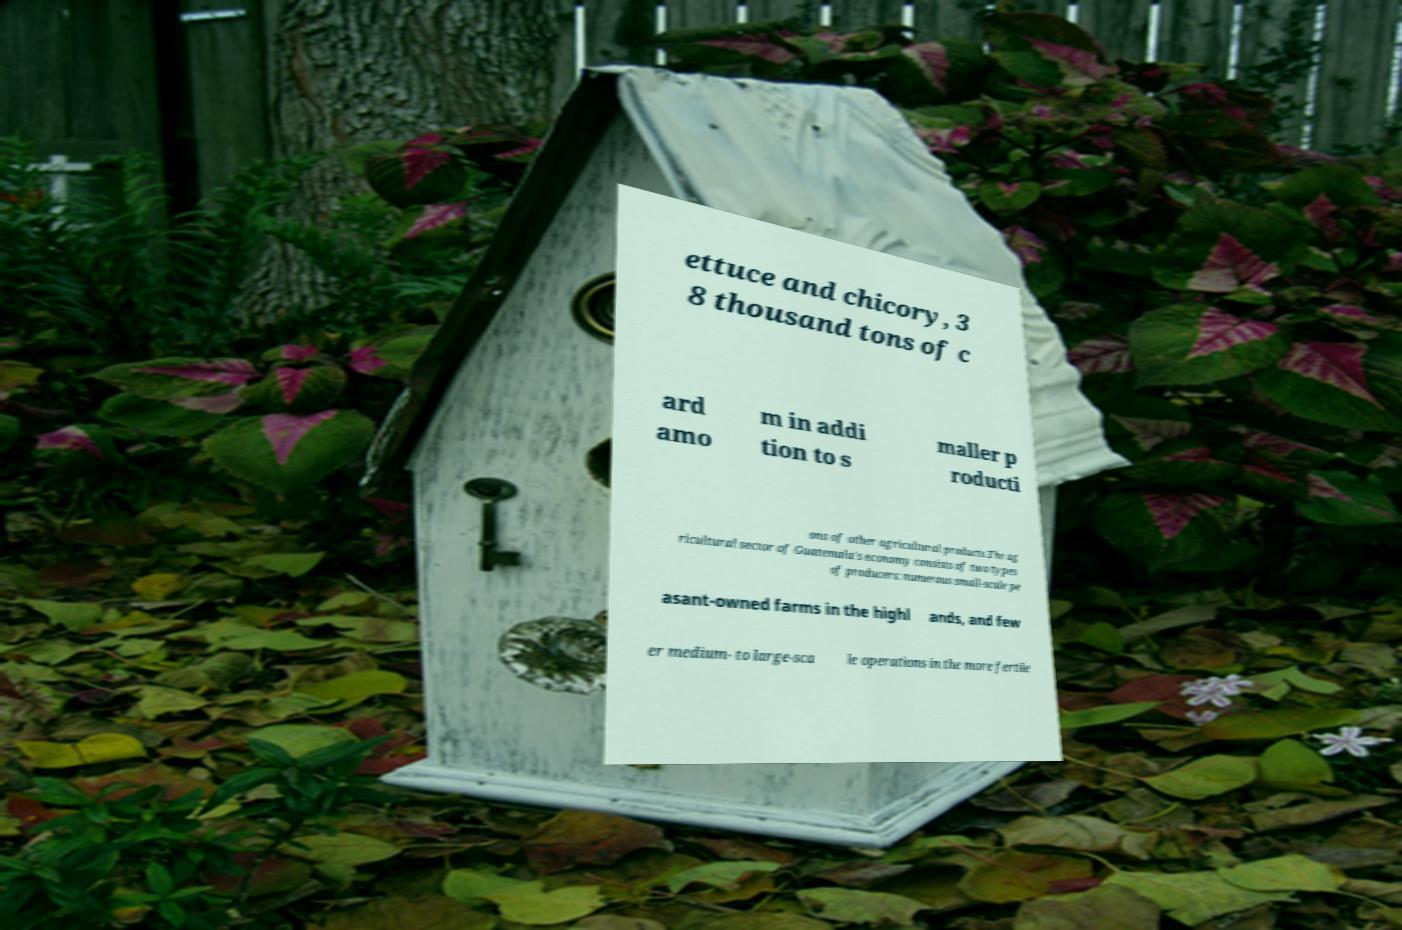Please read and relay the text visible in this image. What does it say? ettuce and chicory, 3 8 thousand tons of c ard amo m in addi tion to s maller p roducti ons of other agricultural products.The ag ricultural sector of Guatemala's economy consists of two types of producers: numerous small-scale pe asant-owned farms in the highl ands, and few er medium- to large-sca le operations in the more fertile 